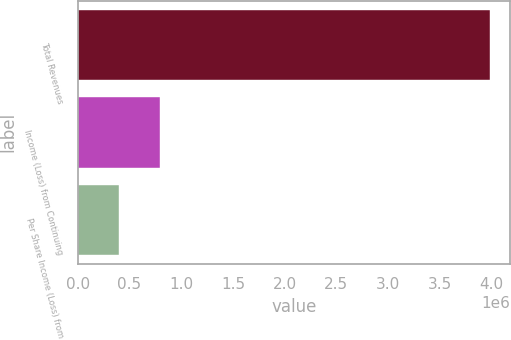<chart> <loc_0><loc_0><loc_500><loc_500><bar_chart><fcel>Total Revenues<fcel>Income (Loss) from Continuing<fcel>Per Share Income (Loss) from<nl><fcel>3.98302e+06<fcel>796604<fcel>398302<nl></chart> 